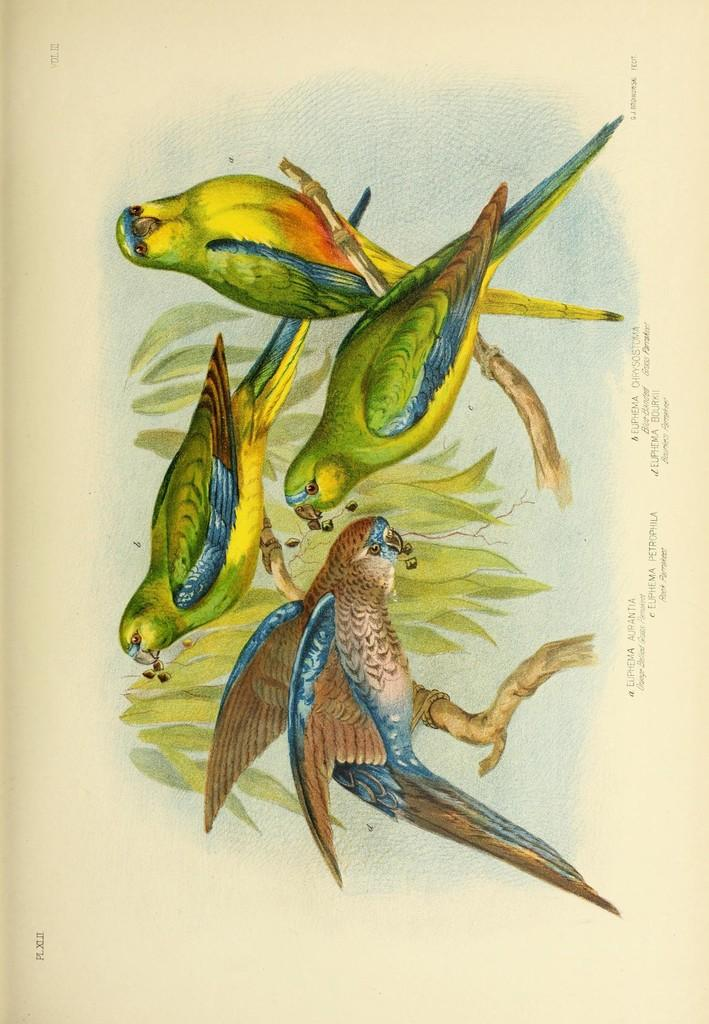What is depicted in the painting in the image? The painting contains a depiction of birds. What else is included in the painting besides the birds? The painting includes branches and leaves. What is the medium of the painting? The painting is on a piece of paper. Is there any text present on the paper? Yes, there is writing on the paper. How does the stranger's digestion affect the painting in the image? There is no stranger present in the image, and therefore their digestion cannot affect the painting. 